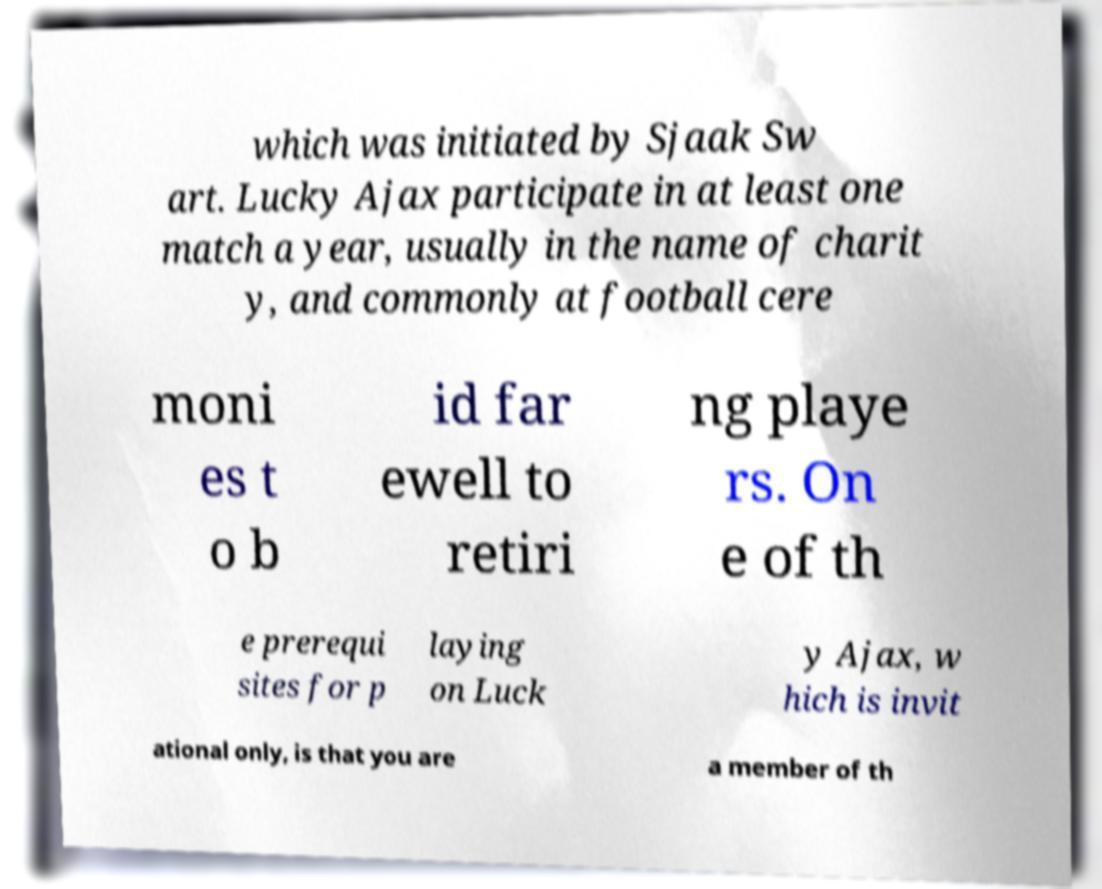There's text embedded in this image that I need extracted. Can you transcribe it verbatim? which was initiated by Sjaak Sw art. Lucky Ajax participate in at least one match a year, usually in the name of charit y, and commonly at football cere moni es t o b id far ewell to retiri ng playe rs. On e of th e prerequi sites for p laying on Luck y Ajax, w hich is invit ational only, is that you are a member of th 